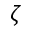<formula> <loc_0><loc_0><loc_500><loc_500>\zeta</formula> 